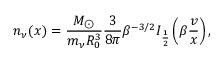Convert formula to latex. <formula><loc_0><loc_0><loc_500><loc_500>n _ { \nu } ( x ) = \frac { M _ { \odot } } { m _ { \nu } R _ { 0 } ^ { 3 } } \frac { 3 } { 8 \pi } \beta ^ { - 3 / 2 } I _ { \frac { 1 } { 2 } } \left ( \beta \frac { v } { x } \right ) ,</formula> 